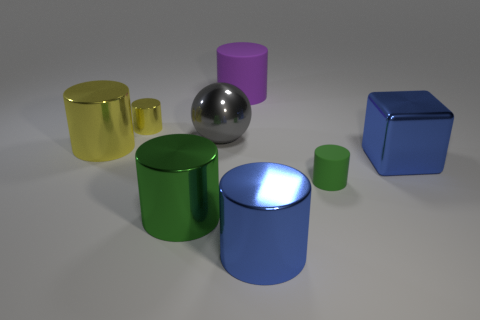Subtract all big blue cylinders. How many cylinders are left? 5 Subtract all blocks. How many objects are left? 7 Add 2 tiny blue rubber things. How many objects exist? 10 Subtract all green cylinders. How many cylinders are left? 4 Subtract 0 yellow spheres. How many objects are left? 8 Subtract 3 cylinders. How many cylinders are left? 3 Subtract all blue spheres. Subtract all green blocks. How many spheres are left? 1 Subtract all gray spheres. How many blue cylinders are left? 1 Subtract all large purple objects. Subtract all big shiny cylinders. How many objects are left? 4 Add 7 yellow metallic cylinders. How many yellow metallic cylinders are left? 9 